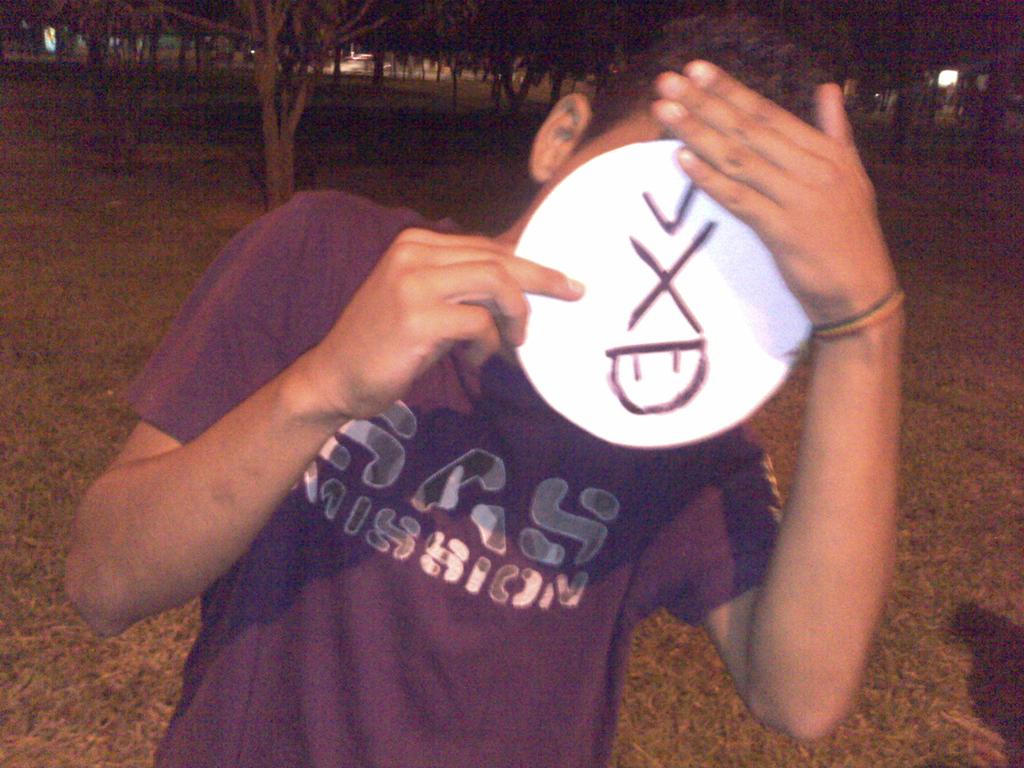What letter is on the white circle?
Give a very brief answer. X. 